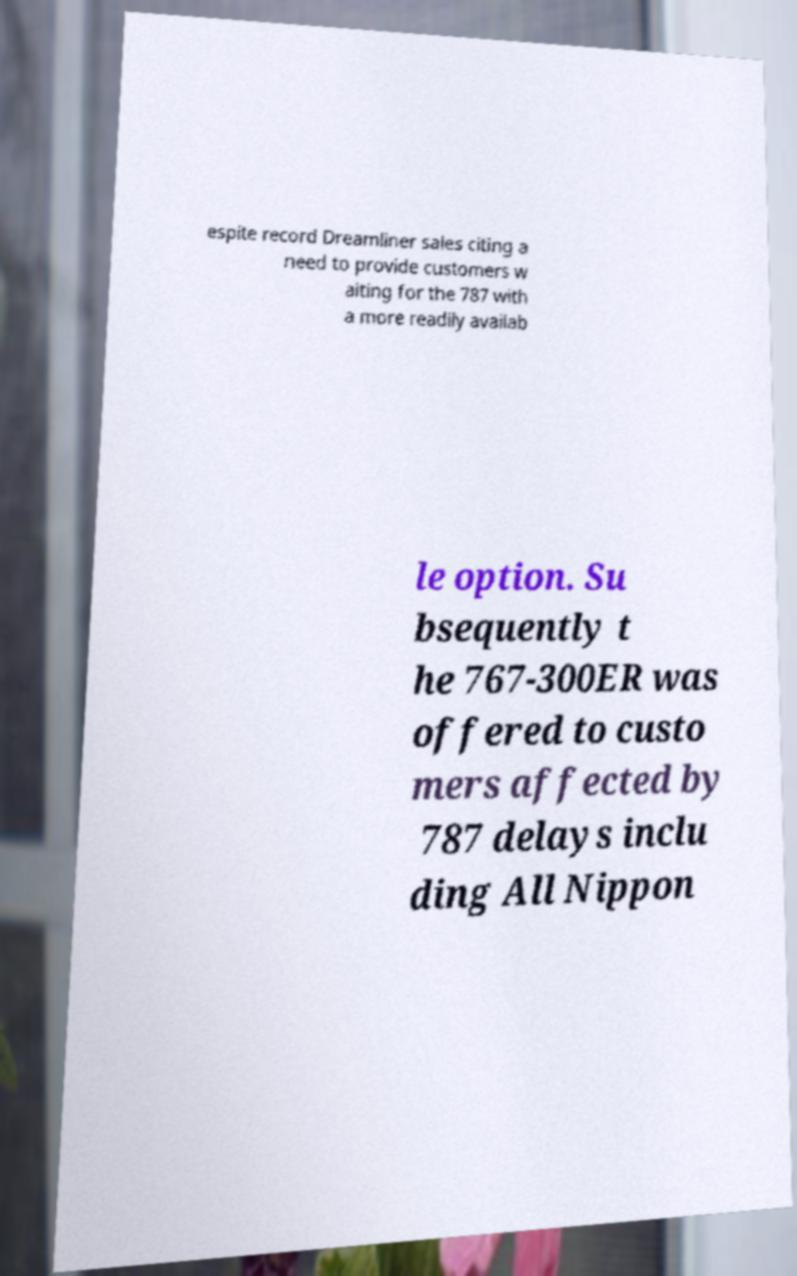Can you accurately transcribe the text from the provided image for me? espite record Dreamliner sales citing a need to provide customers w aiting for the 787 with a more readily availab le option. Su bsequently t he 767-300ER was offered to custo mers affected by 787 delays inclu ding All Nippon 